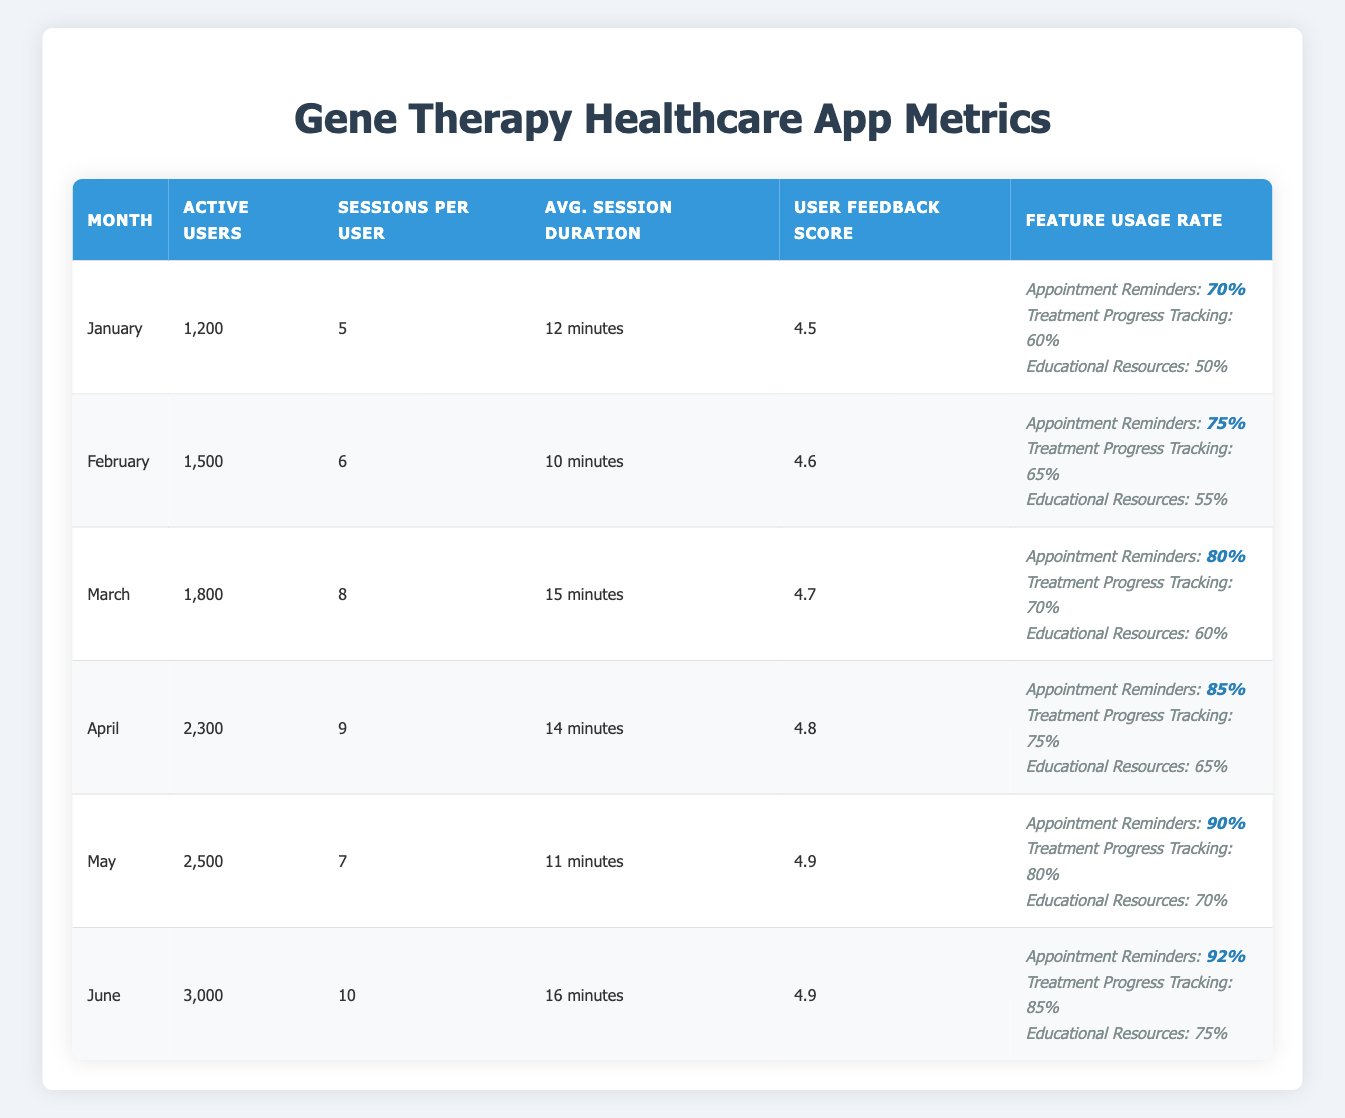What was the user feedback score in March? The table shows that the user feedback score for March is listed under the corresponding month, which is 4.7.
Answer: 4.7 Which month had the highest number of active users? Looking at the "Active Users" column, June has the highest count of active users at 3,000.
Answer: June How many sessions per user were recorded in April? In the "Sessions per User" column, April shows a value of 9 sessions per user.
Answer: 9 What is the average session duration for the six months? To calculate the average session duration, we convert all durations to minutes: 12, 10, 15, 14, 11, and 16 minutes, then sum them up (12 + 10 + 15 + 14 + 11 + 16 = 78) and divide by 6, which gives us an average of 13 minutes.
Answer: 13 minutes Was the feature usage rate for appointment reminders greater than 80% in any of the recorded months? By checking each month’s feature usage rate for appointment reminders, we see that it was greater than 80% in April (85%), May (90%), and June (92%). Therefore, the answer is yes.
Answer: Yes What was the percentage increase in the number of active users from January to June? The number of active users increased from 1,200 in January to 3,000 in June. The increase is (3,000 - 1,200) = 1,800. To find the percentage increase, divide the increase by the original number and multiply by 100: (1,800 / 1,200) * 100 = 150%.
Answer: 150% Which month had the highest feature usage rate for treatment progress tracking? By looking at the "Feature Usage Rate," we see that the highest rate for treatment progress tracking was in June at 85%.
Answer: June What was the difference in average session duration between the months with the highest and lowest durations? The highest average session duration was in June at 16 minutes and the lowest was in February at 10 minutes. The difference is (16 - 10 = 6 minutes).
Answer: 6 minutes How did user feedback scores trend over the six months? Observing the "User Feedback Score" column, the score increased consecutively from 4.5 in January to 4.9 in both May and June, indicating a positive trend.
Answer: Positive trend Was the number of sessions per user lower in May than in February? Looking at the "Sessions per User" column, May had 7 sessions per user, while February had 6 sessions per user, indicating it was not lower.
Answer: No What was the combined total of active users for the first three months? Adding the active users for January (1,200), February (1,500), and March (1,800): 1,200 + 1,500 + 1,800 = 4,500.
Answer: 4,500 